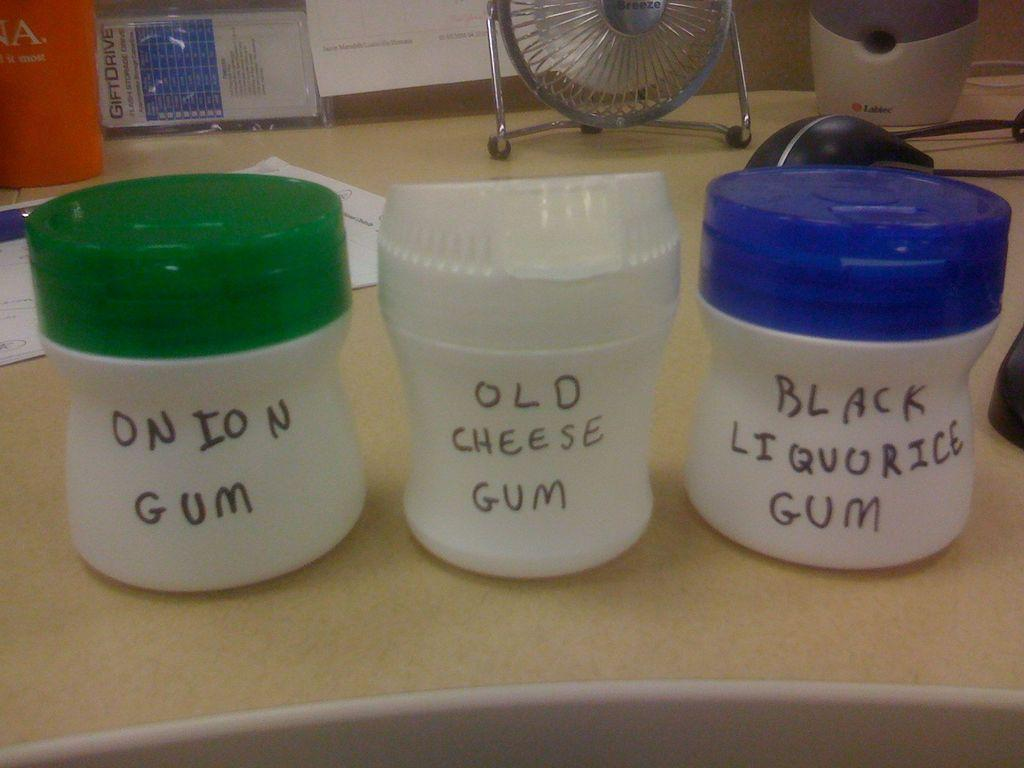<image>
Give a short and clear explanation of the subsequent image. three containers with three different type of gum 